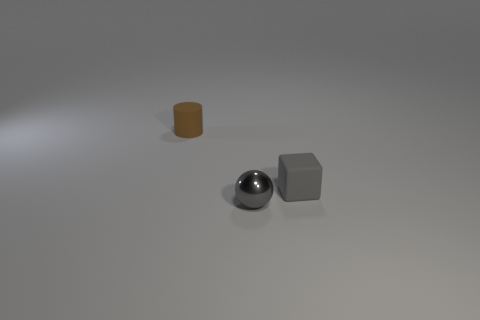Add 1 tiny matte cylinders. How many objects exist? 4 Subtract all spheres. How many objects are left? 2 Add 3 cyan spheres. How many cyan spheres exist? 3 Subtract 0 yellow blocks. How many objects are left? 3 Subtract all big yellow shiny cylinders. Subtract all small rubber cylinders. How many objects are left? 2 Add 1 gray balls. How many gray balls are left? 2 